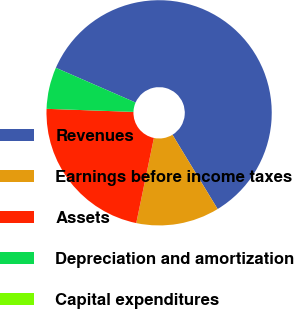<chart> <loc_0><loc_0><loc_500><loc_500><pie_chart><fcel>Revenues<fcel>Earnings before income taxes<fcel>Assets<fcel>Depreciation and amortization<fcel>Capital expenditures<nl><fcel>59.76%<fcel>11.95%<fcel>22.31%<fcel>5.98%<fcel>0.0%<nl></chart> 